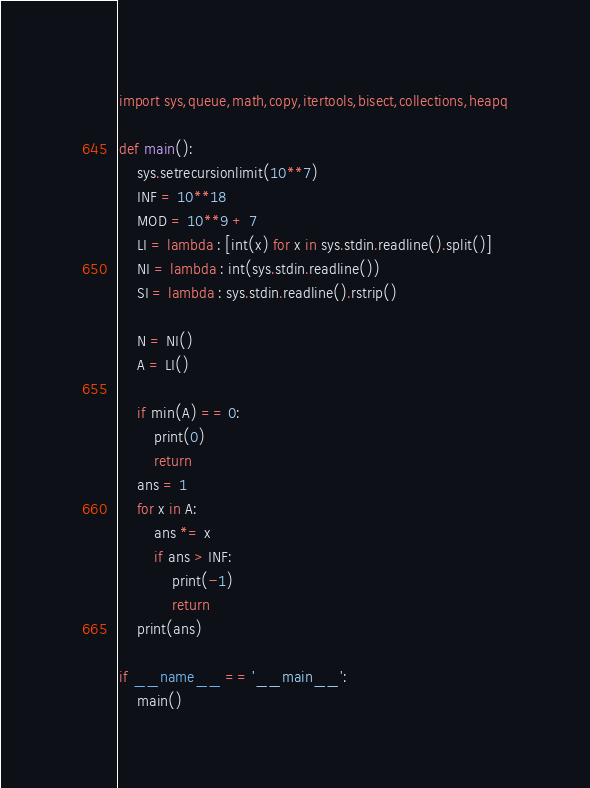<code> <loc_0><loc_0><loc_500><loc_500><_Python_>import sys,queue,math,copy,itertools,bisect,collections,heapq

def main():
    sys.setrecursionlimit(10**7)
    INF = 10**18
    MOD = 10**9 + 7
    LI = lambda : [int(x) for x in sys.stdin.readline().split()]
    NI = lambda : int(sys.stdin.readline())
    SI = lambda : sys.stdin.readline().rstrip()

    N = NI()
    A = LI()

    if min(A) == 0:
        print(0)
        return
    ans = 1
    for x in A:
        ans *= x
        if ans > INF:
            print(-1)
            return
    print(ans)

if __name__ == '__main__':
    main()</code> 